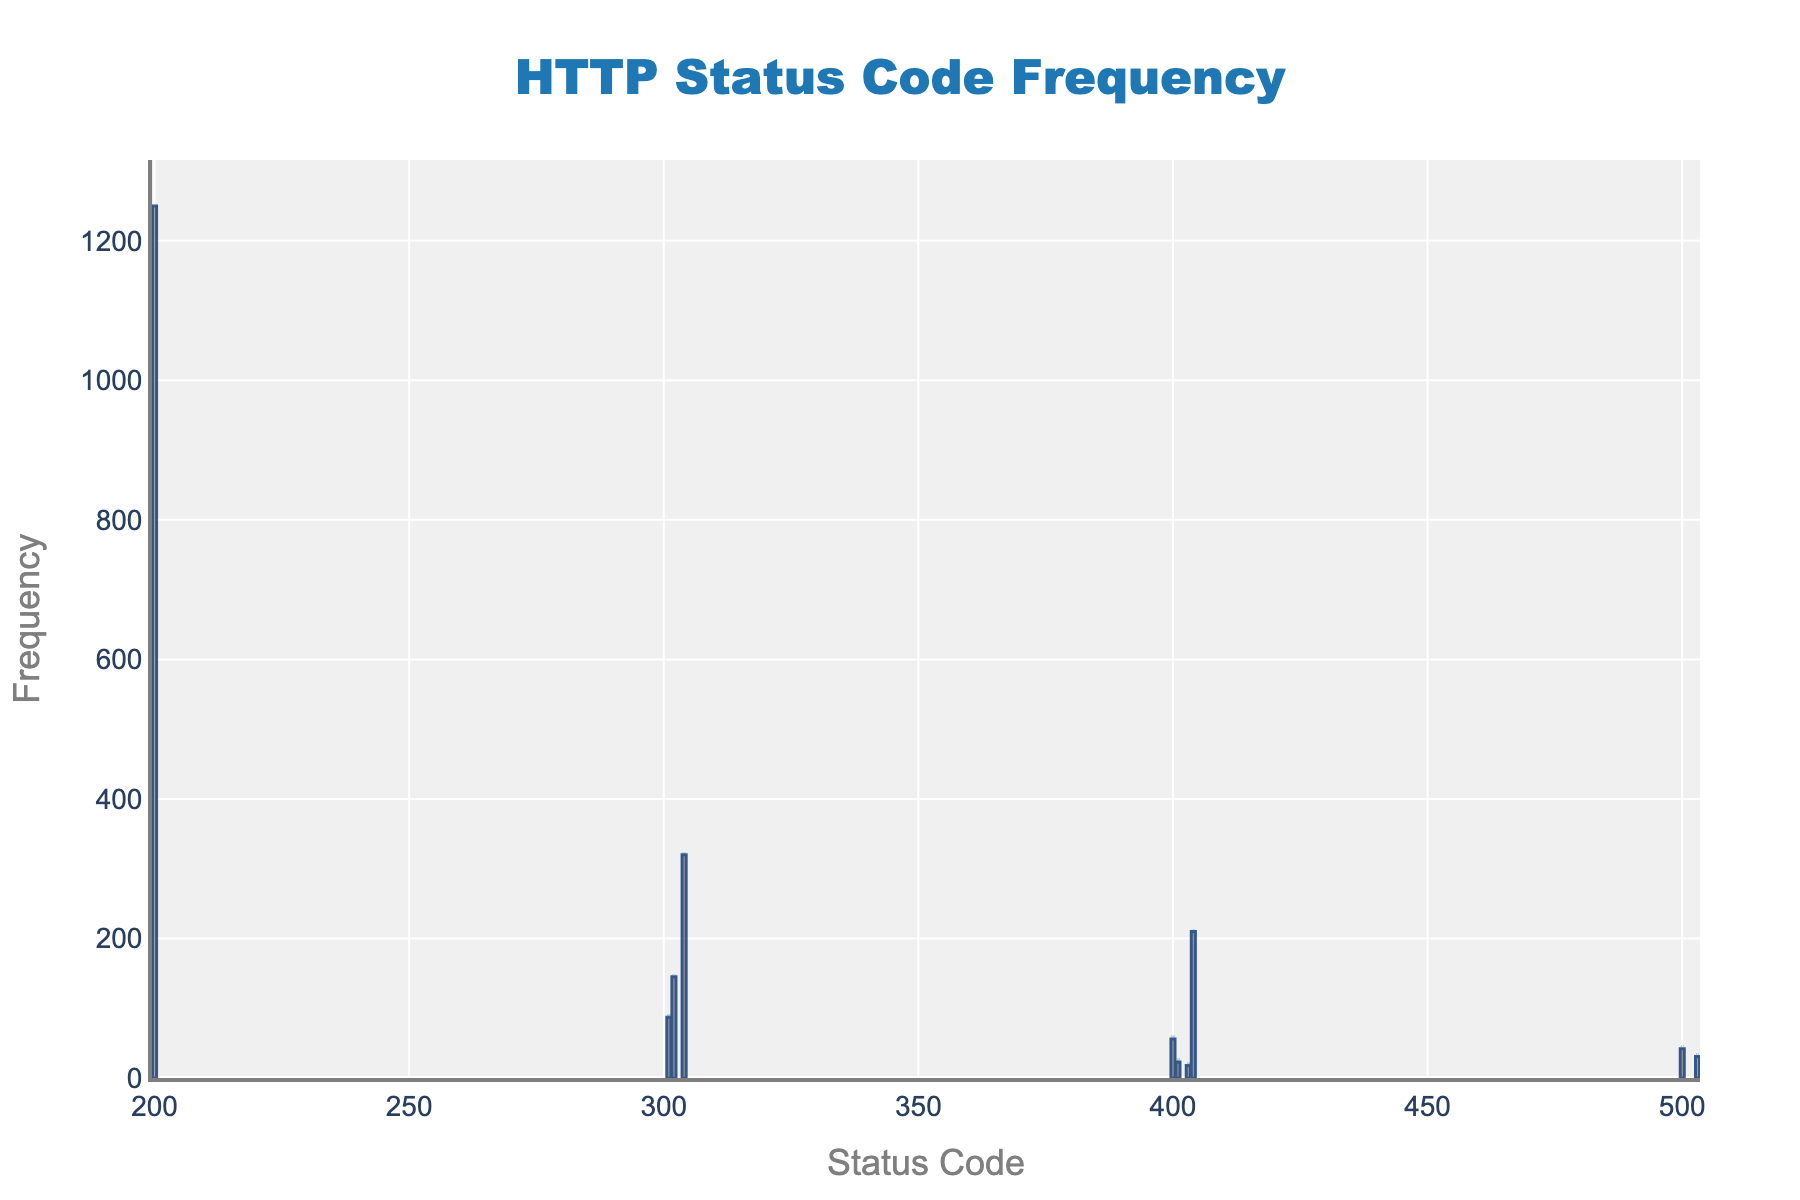What is the title of the histogram? The title is displayed at the top of the histogram in a larger font. It indicates the subject of the plot.
Answer: HTTP Status Code Frequency Which status code has the highest frequency? The status code with the tallest bar represents the highest frequency. By looking at the plot, the tallest bar corresponds to the status code 200.
Answer: 200 How many status codes have a frequency greater than 100? Identify the bars that are taller than the marker corresponding to a frequency of 100. The status codes 200, 302, 304, and 404 meet this criterion.
Answer: 4 What is the total frequency of all 5xx status codes combined? Sum the frequencies of the two 5xx status codes (500 and 503) from the bars in the histogram. The frequencies are 42 and 31 respectively. 42 + 31 = 73.
Answer: 73 Which status code has the lowest frequency? The bar representing the status code with the shortest length indicates the lowest frequency. The status code 403 has the shortest bar.
Answer: 403 What is the frequency difference between the status codes 200 and 404? Subtract the frequency of status code 404 from the frequency of status code 200. The values are 1250 and 210 respectively. 1250 - 210 = 1040.
Answer: 1040 How many status codes have a frequency less than 50? Identify the bars that are shorter than the marker corresponding to a frequency of 50. The status codes 401 and 403 meet this criterion.
Answer: 2 What is the average frequency of the status codes 4xx and 5xx? First, sum the frequencies of 4xx (56 + 23 + 18 + 210 = 307) and 5xx (42 + 31 = 73). Then, divide by the number of status codes (7). (307 + 73) / 7 ≈ 54.29.
Answer: 54.29 Which two status codes have frequencies closest to each other? Compare the frequencies to find the smallest difference. The frequencies 401 (23) and 403 (18) have a difference of 5, which is the smallest.
Answer: 401 and 403 What's the total number of status codes represented in the histogram? Count the number of distinct bars or categories on the x-axis. The status codes are 200, 301, 302, 304, 400, 401, 403, 404, 500, and 503.
Answer: 10 